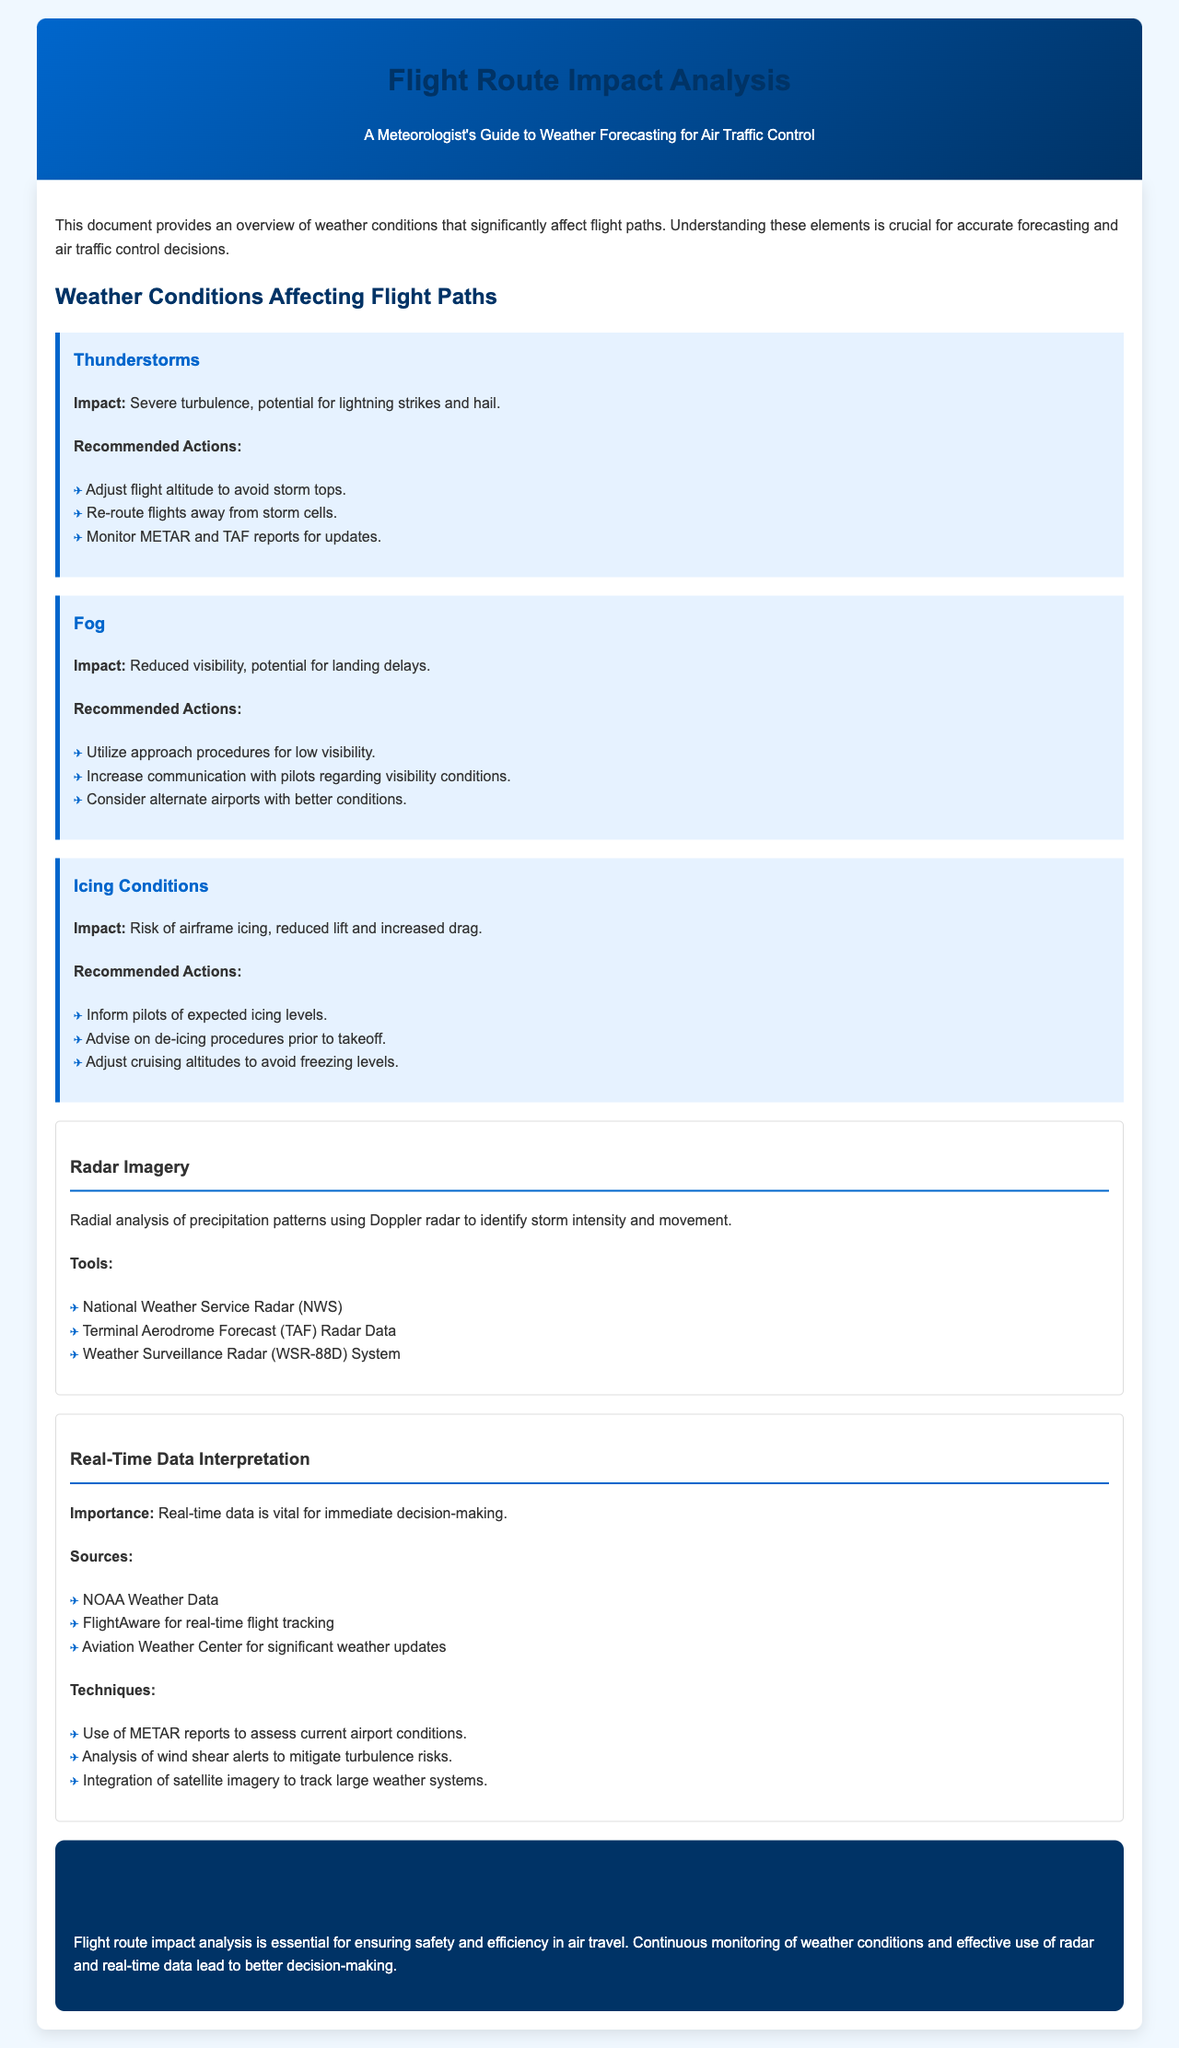What is the main purpose of this manual? The manual provides an overview of weather conditions that significantly affect flight paths for accurate forecasting and air traffic control decisions.
Answer: Overview of weather conditions What weather condition is associated with reduced visibility? The document states that fog is known to cause reduced visibility, impacting landing.
Answer: Fog What is one recommended action to take during thunderstorms? The document lists adjusting flight altitude to avoid storm tops as a recommended action during thunderstorms.
Answer: Adjust flight altitude What tools are mentioned for analyzing radar imagery? The manual lists National Weather Service Radar, Terminal Aerodrome Forecast Radar Data, and Weather Surveillance Radar System as tools for radar imagery analysis.
Answer: NWS, TAF, WSR-88D What is the significance of real-time data? Real-time data is vital for immediate decision-making in weather analysis and air traffic control.
Answer: Immediate decision-making What is the recommended action regarding icing conditions? The manual advises informing pilots of expected icing levels to ensure safety during flight.
Answer: Inform pilots Which weather condition is linked to severe turbulence? Thunderstorms are associated with severe turbulence and other risks such as lightning strikes.
Answer: Thunderstorms What is a critical source for significant weather updates? The document states that the Aviation Weather Center is a critical source for significant weather updates.
Answer: Aviation Weather Center What type of report can be used to assess current airport conditions? The METAR report is indicated as a useful tool for assessing current airport conditions.
Answer: METAR report 